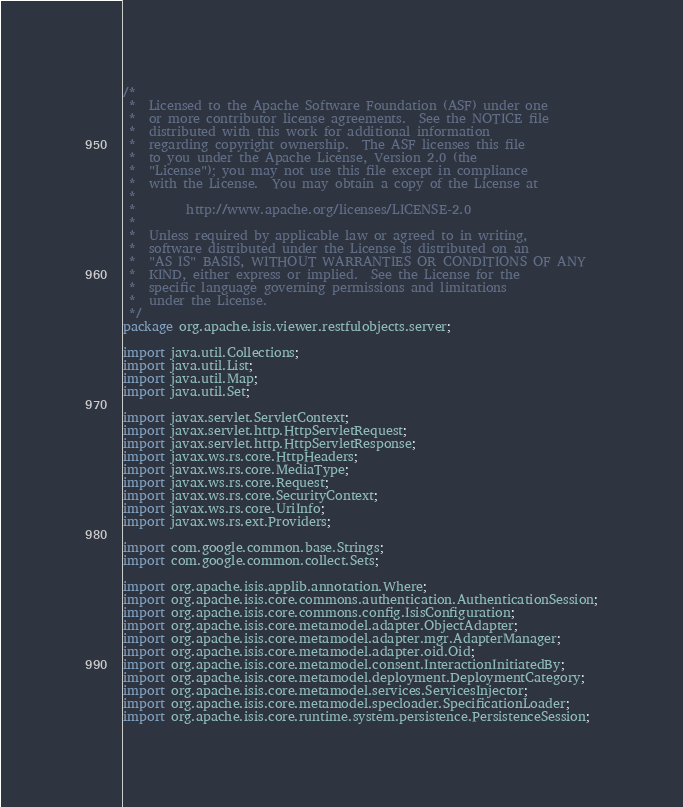Convert code to text. <code><loc_0><loc_0><loc_500><loc_500><_Java_>/*
 *  Licensed to the Apache Software Foundation (ASF) under one
 *  or more contributor license agreements.  See the NOTICE file
 *  distributed with this work for additional information
 *  regarding copyright ownership.  The ASF licenses this file
 *  to you under the Apache License, Version 2.0 (the
 *  "License"); you may not use this file except in compliance
 *  with the License.  You may obtain a copy of the License at
 *
 *        http://www.apache.org/licenses/LICENSE-2.0
 *
 *  Unless required by applicable law or agreed to in writing,
 *  software distributed under the License is distributed on an
 *  "AS IS" BASIS, WITHOUT WARRANTIES OR CONDITIONS OF ANY
 *  KIND, either express or implied.  See the License for the
 *  specific language governing permissions and limitations
 *  under the License.
 */
package org.apache.isis.viewer.restfulobjects.server;

import java.util.Collections;
import java.util.List;
import java.util.Map;
import java.util.Set;

import javax.servlet.ServletContext;
import javax.servlet.http.HttpServletRequest;
import javax.servlet.http.HttpServletResponse;
import javax.ws.rs.core.HttpHeaders;
import javax.ws.rs.core.MediaType;
import javax.ws.rs.core.Request;
import javax.ws.rs.core.SecurityContext;
import javax.ws.rs.core.UriInfo;
import javax.ws.rs.ext.Providers;

import com.google.common.base.Strings;
import com.google.common.collect.Sets;

import org.apache.isis.applib.annotation.Where;
import org.apache.isis.core.commons.authentication.AuthenticationSession;
import org.apache.isis.core.commons.config.IsisConfiguration;
import org.apache.isis.core.metamodel.adapter.ObjectAdapter;
import org.apache.isis.core.metamodel.adapter.mgr.AdapterManager;
import org.apache.isis.core.metamodel.adapter.oid.Oid;
import org.apache.isis.core.metamodel.consent.InteractionInitiatedBy;
import org.apache.isis.core.metamodel.deployment.DeploymentCategory;
import org.apache.isis.core.metamodel.services.ServicesInjector;
import org.apache.isis.core.metamodel.specloader.SpecificationLoader;
import org.apache.isis.core.runtime.system.persistence.PersistenceSession;</code> 